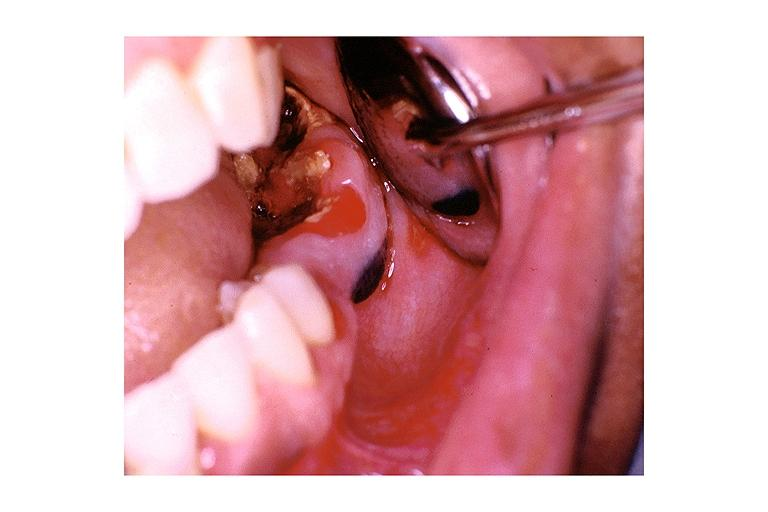where is this?
Answer the question using a single word or phrase. Oral 